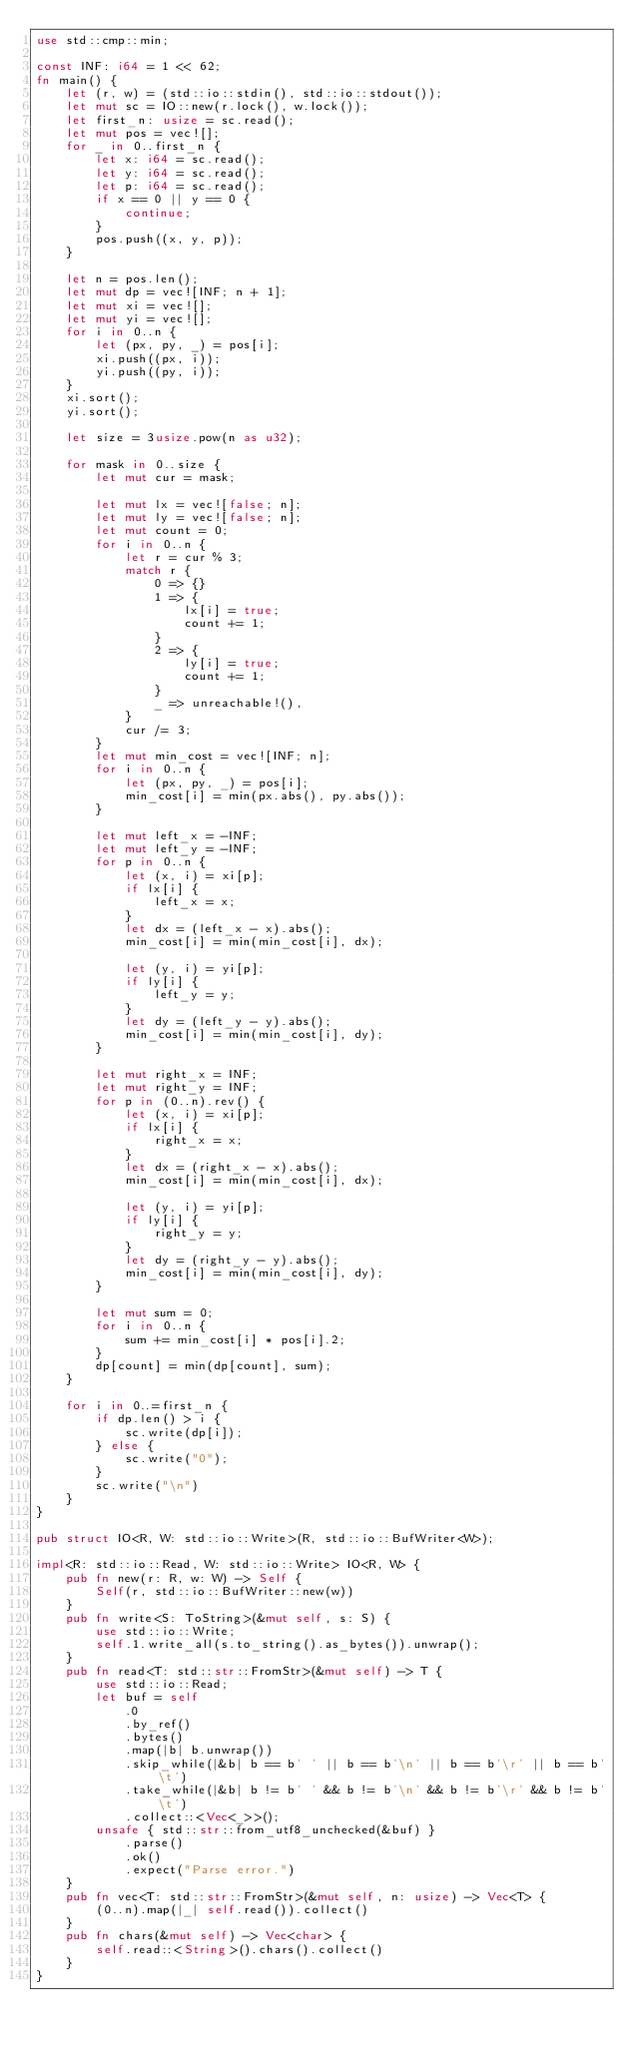Convert code to text. <code><loc_0><loc_0><loc_500><loc_500><_Rust_>use std::cmp::min;

const INF: i64 = 1 << 62;
fn main() {
    let (r, w) = (std::io::stdin(), std::io::stdout());
    let mut sc = IO::new(r.lock(), w.lock());
    let first_n: usize = sc.read();
    let mut pos = vec![];
    for _ in 0..first_n {
        let x: i64 = sc.read();
        let y: i64 = sc.read();
        let p: i64 = sc.read();
        if x == 0 || y == 0 {
            continue;
        }
        pos.push((x, y, p));
    }

    let n = pos.len();
    let mut dp = vec![INF; n + 1];
    let mut xi = vec![];
    let mut yi = vec![];
    for i in 0..n {
        let (px, py, _) = pos[i];
        xi.push((px, i));
        yi.push((py, i));
    }
    xi.sort();
    yi.sort();

    let size = 3usize.pow(n as u32);

    for mask in 0..size {
        let mut cur = mask;

        let mut lx = vec![false; n];
        let mut ly = vec![false; n];
        let mut count = 0;
        for i in 0..n {
            let r = cur % 3;
            match r {
                0 => {}
                1 => {
                    lx[i] = true;
                    count += 1;
                }
                2 => {
                    ly[i] = true;
                    count += 1;
                }
                _ => unreachable!(),
            }
            cur /= 3;
        }
        let mut min_cost = vec![INF; n];
        for i in 0..n {
            let (px, py, _) = pos[i];
            min_cost[i] = min(px.abs(), py.abs());
        }

        let mut left_x = -INF;
        let mut left_y = -INF;
        for p in 0..n {
            let (x, i) = xi[p];
            if lx[i] {
                left_x = x;
            }
            let dx = (left_x - x).abs();
            min_cost[i] = min(min_cost[i], dx);

            let (y, i) = yi[p];
            if ly[i] {
                left_y = y;
            }
            let dy = (left_y - y).abs();
            min_cost[i] = min(min_cost[i], dy);
        }

        let mut right_x = INF;
        let mut right_y = INF;
        for p in (0..n).rev() {
            let (x, i) = xi[p];
            if lx[i] {
                right_x = x;
            }
            let dx = (right_x - x).abs();
            min_cost[i] = min(min_cost[i], dx);

            let (y, i) = yi[p];
            if ly[i] {
                right_y = y;
            }
            let dy = (right_y - y).abs();
            min_cost[i] = min(min_cost[i], dy);
        }

        let mut sum = 0;
        for i in 0..n {
            sum += min_cost[i] * pos[i].2;
        }
        dp[count] = min(dp[count], sum);
    }

    for i in 0..=first_n {
        if dp.len() > i {
            sc.write(dp[i]);
        } else {
            sc.write("0");
        }
        sc.write("\n")
    }
}

pub struct IO<R, W: std::io::Write>(R, std::io::BufWriter<W>);

impl<R: std::io::Read, W: std::io::Write> IO<R, W> {
    pub fn new(r: R, w: W) -> Self {
        Self(r, std::io::BufWriter::new(w))
    }
    pub fn write<S: ToString>(&mut self, s: S) {
        use std::io::Write;
        self.1.write_all(s.to_string().as_bytes()).unwrap();
    }
    pub fn read<T: std::str::FromStr>(&mut self) -> T {
        use std::io::Read;
        let buf = self
            .0
            .by_ref()
            .bytes()
            .map(|b| b.unwrap())
            .skip_while(|&b| b == b' ' || b == b'\n' || b == b'\r' || b == b'\t')
            .take_while(|&b| b != b' ' && b != b'\n' && b != b'\r' && b != b'\t')
            .collect::<Vec<_>>();
        unsafe { std::str::from_utf8_unchecked(&buf) }
            .parse()
            .ok()
            .expect("Parse error.")
    }
    pub fn vec<T: std::str::FromStr>(&mut self, n: usize) -> Vec<T> {
        (0..n).map(|_| self.read()).collect()
    }
    pub fn chars(&mut self) -> Vec<char> {
        self.read::<String>().chars().collect()
    }
}
</code> 